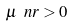<formula> <loc_0><loc_0><loc_500><loc_500>\mu _ { \ } n r > 0</formula> 